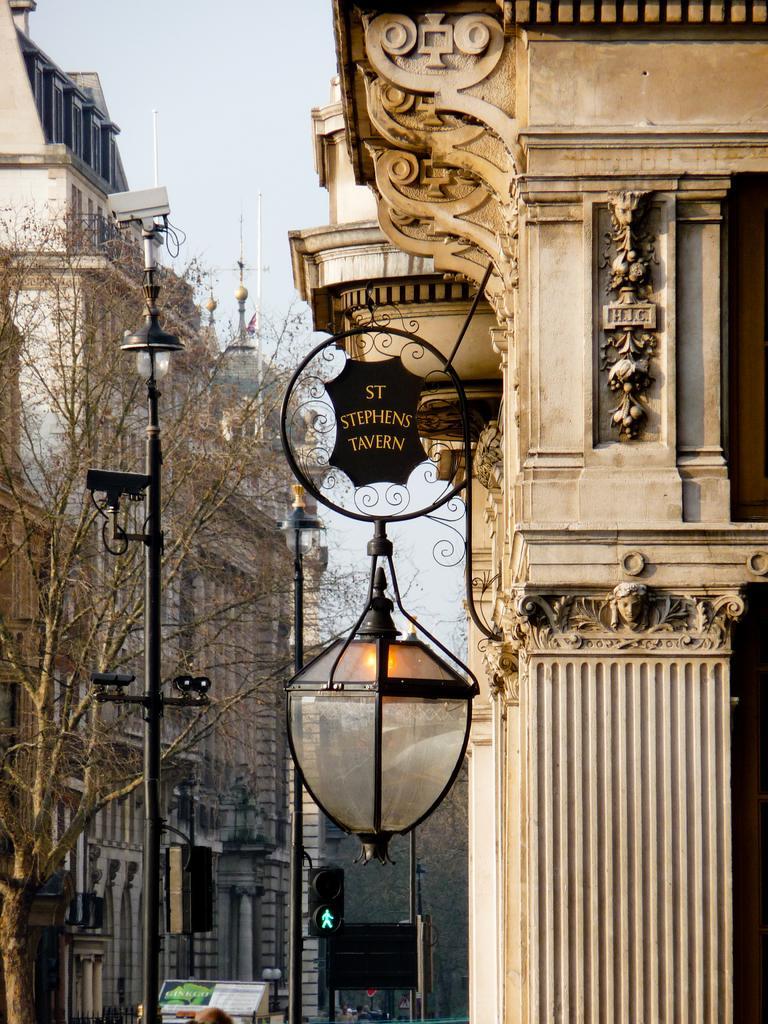Can you describe this image briefly? In this image there are buildings and trees. In the foreground there is a small board hanging to the wall of the building. There is text on the board. Below the board there is a lamp. In between the buildings there are street light poles and traffic signal poles. At the top there is the sky. There are sculptures on the wall of the building. 